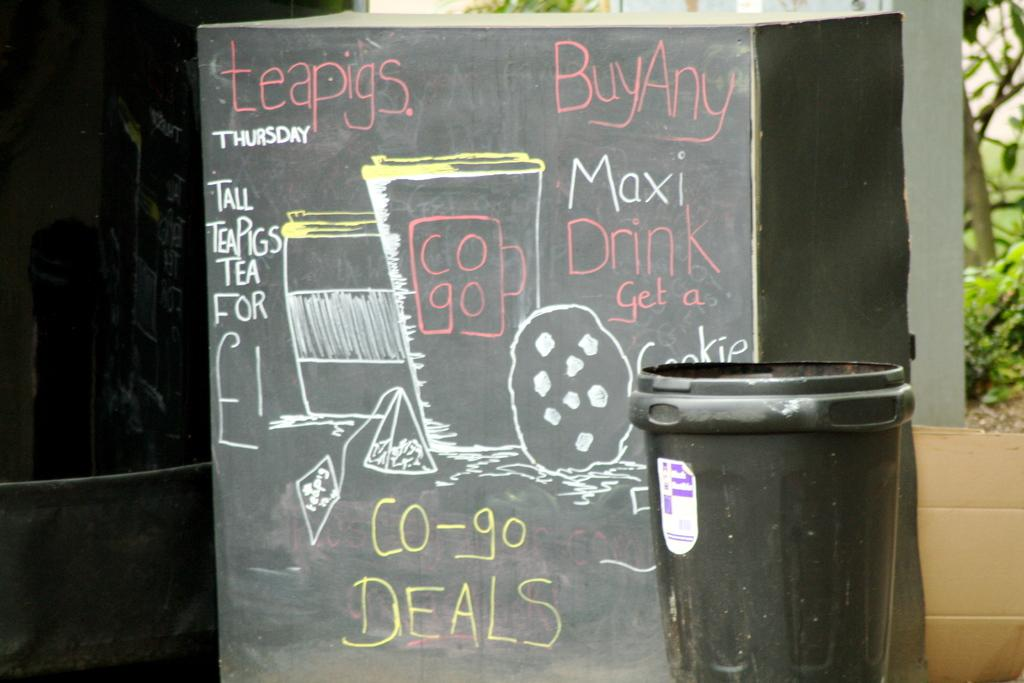<image>
Render a clear and concise summary of the photo. A coffee shop chalkboard with "Buy Any Maxi Get a Cookie" on it. 